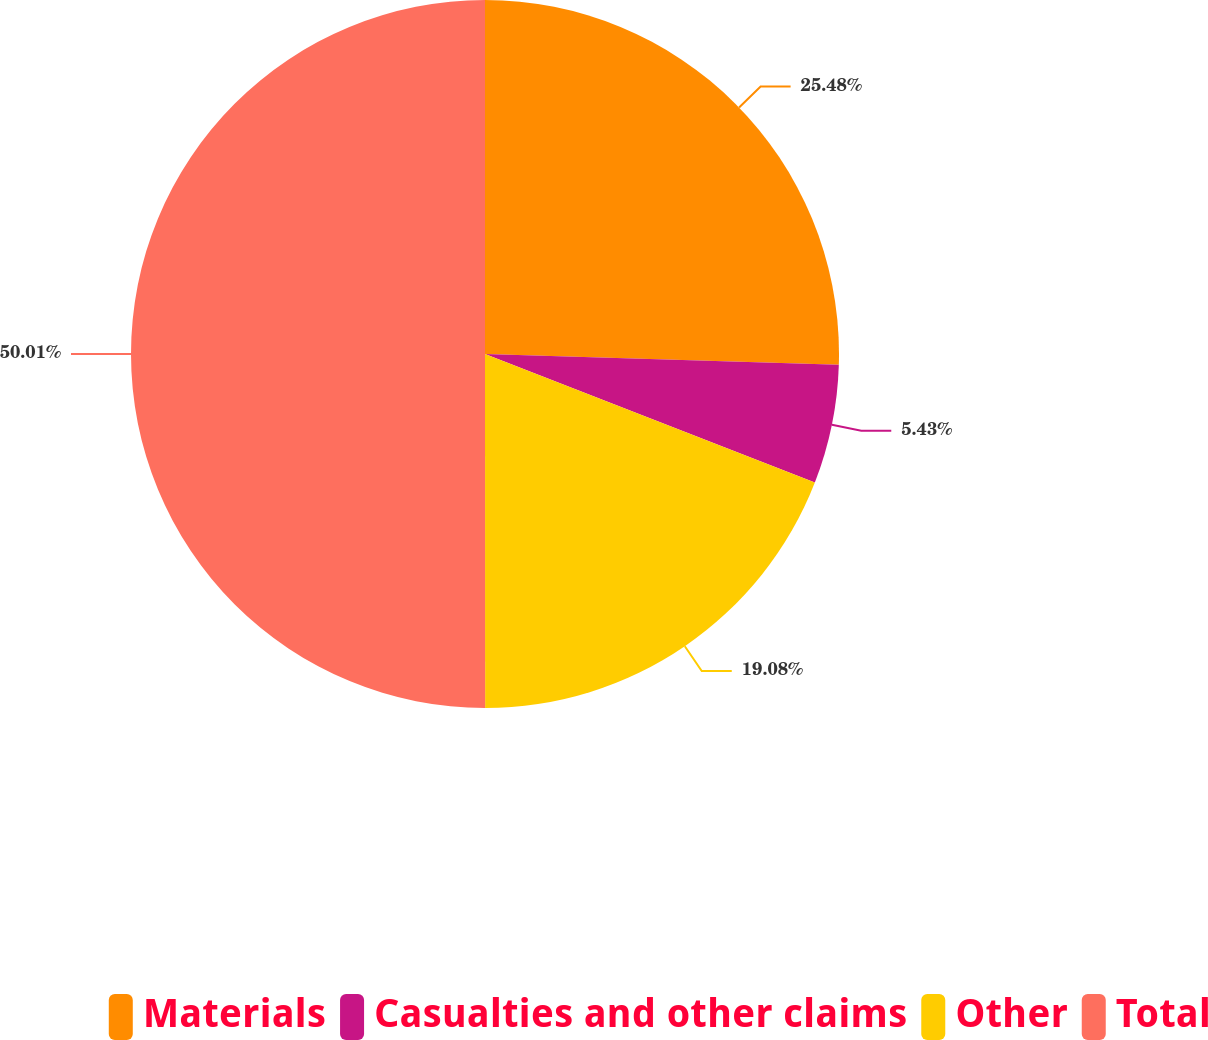Convert chart. <chart><loc_0><loc_0><loc_500><loc_500><pie_chart><fcel>Materials<fcel>Casualties and other claims<fcel>Other<fcel>Total<nl><fcel>25.48%<fcel>5.43%<fcel>19.08%<fcel>50.0%<nl></chart> 